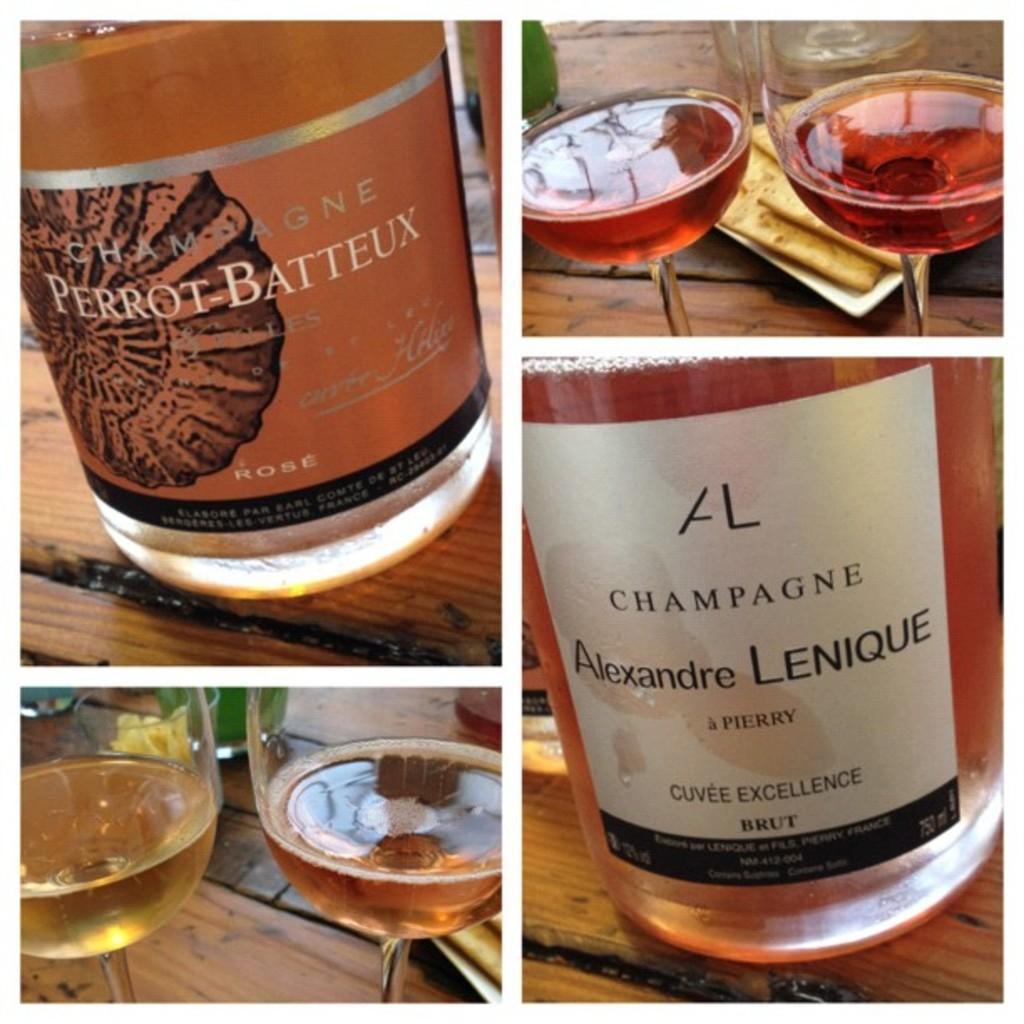<image>
Present a compact description of the photo's key features. A collage of four pictures displays a bottle of Perrot Batteux champagne and a bottle of Alexandre Lenique champagne, as well as wine glasses containing these beverages. 